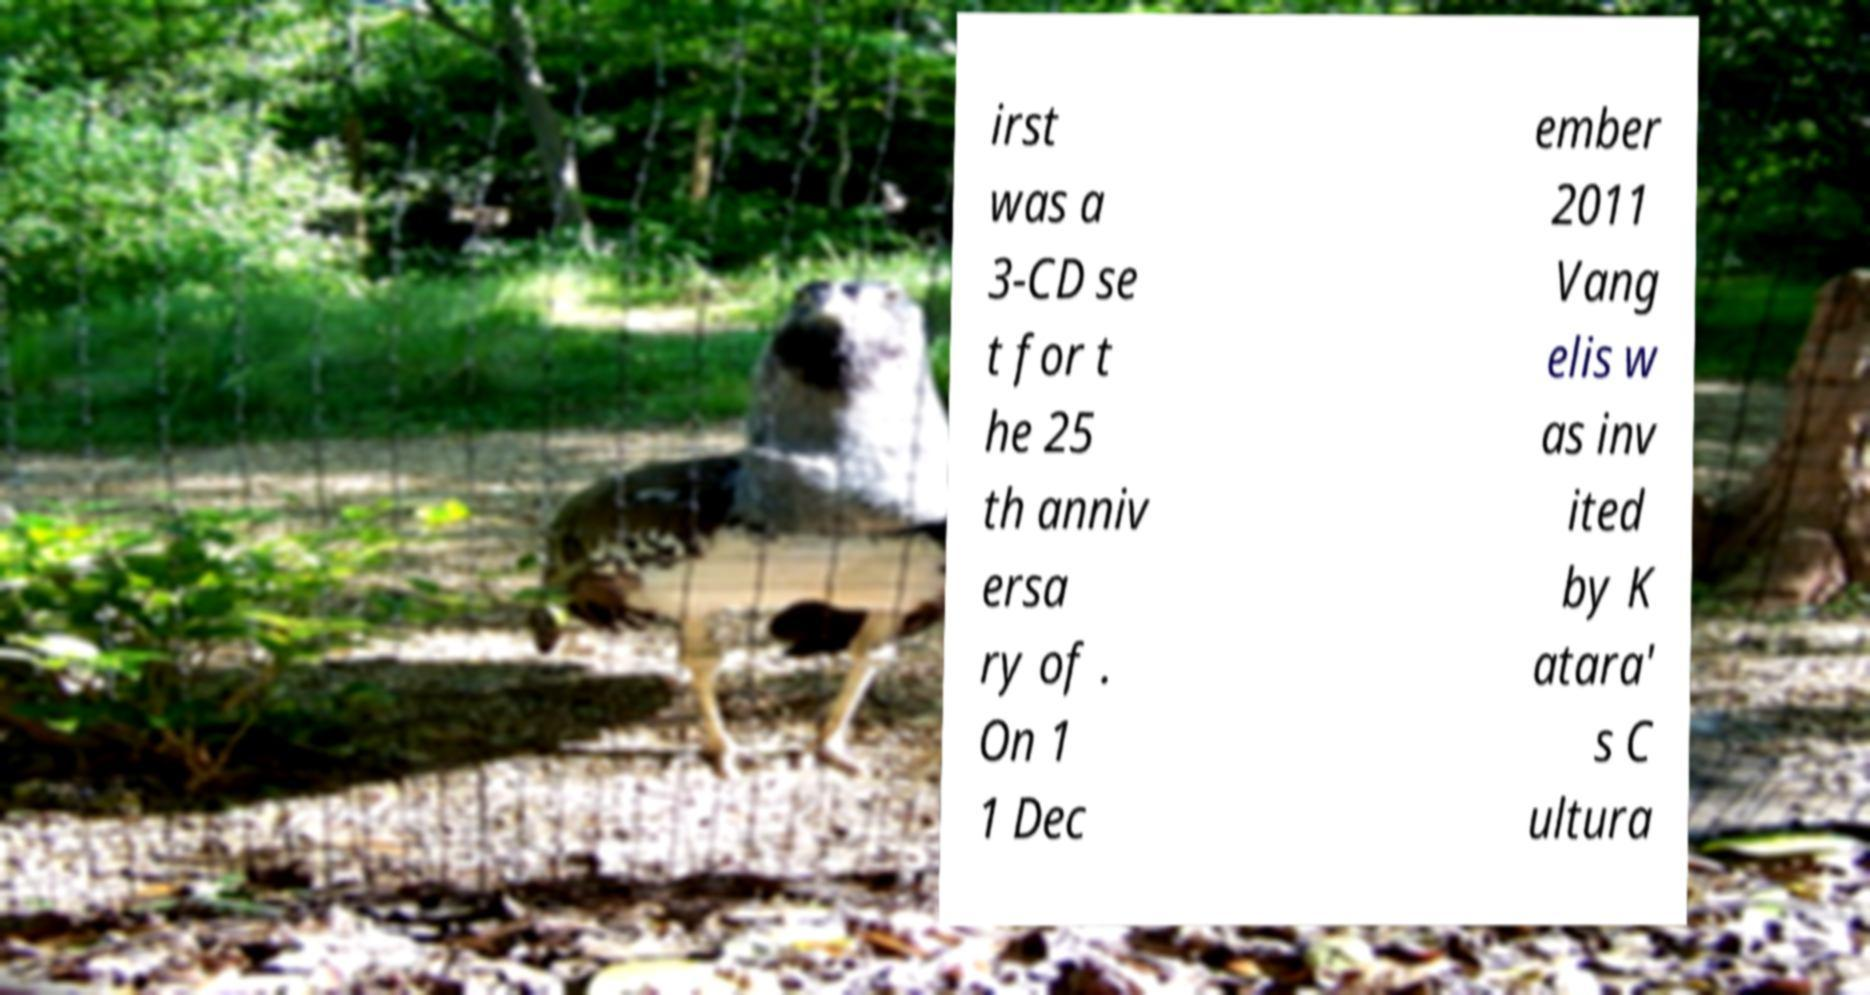What messages or text are displayed in this image? I need them in a readable, typed format. irst was a 3-CD se t for t he 25 th anniv ersa ry of . On 1 1 Dec ember 2011 Vang elis w as inv ited by K atara' s C ultura 